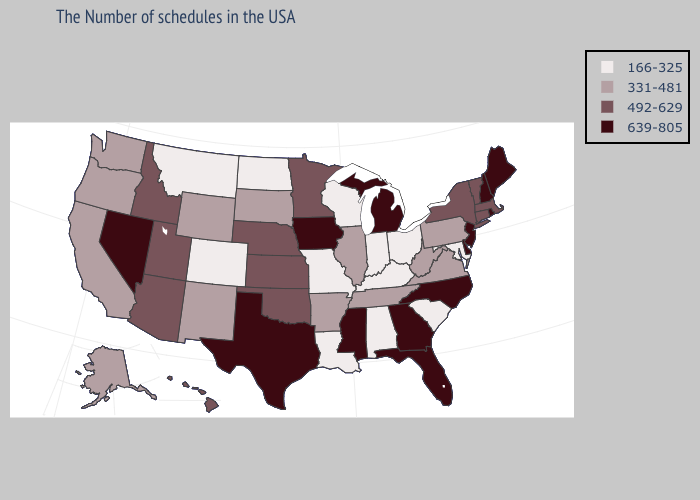Name the states that have a value in the range 331-481?
Answer briefly. Pennsylvania, Virginia, West Virginia, Tennessee, Illinois, Arkansas, South Dakota, Wyoming, New Mexico, California, Washington, Oregon, Alaska. Does Hawaii have a higher value than Kansas?
Give a very brief answer. No. Which states have the lowest value in the Northeast?
Short answer required. Pennsylvania. Does Minnesota have a higher value than Colorado?
Keep it brief. Yes. Name the states that have a value in the range 639-805?
Answer briefly. Maine, Rhode Island, New Hampshire, New Jersey, Delaware, North Carolina, Florida, Georgia, Michigan, Mississippi, Iowa, Texas, Nevada. Name the states that have a value in the range 492-629?
Concise answer only. Massachusetts, Vermont, Connecticut, New York, Minnesota, Kansas, Nebraska, Oklahoma, Utah, Arizona, Idaho, Hawaii. What is the value of Maine?
Short answer required. 639-805. Does South Carolina have the highest value in the USA?
Be succinct. No. What is the highest value in the USA?
Be succinct. 639-805. What is the lowest value in the MidWest?
Quick response, please. 166-325. Does the map have missing data?
Be succinct. No. What is the lowest value in the USA?
Short answer required. 166-325. Does the first symbol in the legend represent the smallest category?
Give a very brief answer. Yes. Does Montana have the lowest value in the West?
Concise answer only. Yes. Does North Carolina have the same value as New Jersey?
Concise answer only. Yes. 